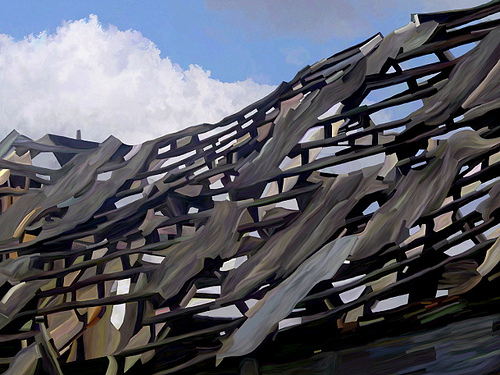<image>
Can you confirm if the sky is behind the cloth? Yes. From this viewpoint, the sky is positioned behind the cloth, with the cloth partially or fully occluding the sky. 